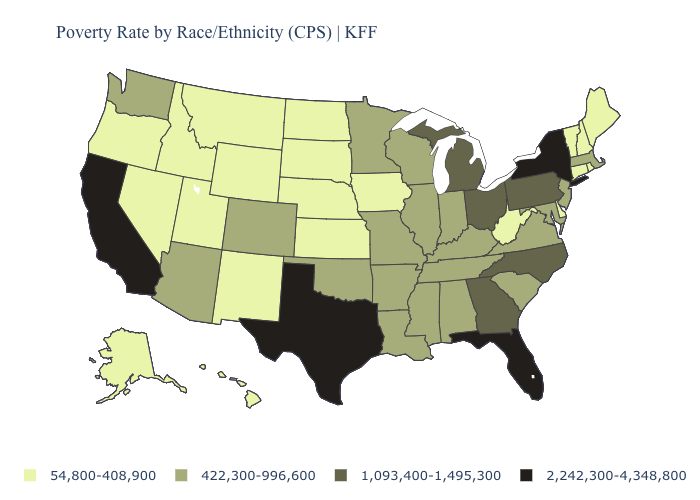Among the states that border New Jersey , does Pennsylvania have the lowest value?
Be succinct. No. What is the value of Washington?
Keep it brief. 422,300-996,600. Which states hav the highest value in the MidWest?
Keep it brief. Michigan, Ohio. What is the lowest value in states that border Maryland?
Be succinct. 54,800-408,900. Among the states that border Utah , does Colorado have the lowest value?
Write a very short answer. No. Among the states that border New Mexico , which have the lowest value?
Answer briefly. Utah. What is the lowest value in states that border Indiana?
Give a very brief answer. 422,300-996,600. What is the value of Vermont?
Be succinct. 54,800-408,900. What is the value of Illinois?
Write a very short answer. 422,300-996,600. What is the lowest value in the Northeast?
Quick response, please. 54,800-408,900. Does Iowa have the lowest value in the MidWest?
Be succinct. Yes. Among the states that border New Hampshire , which have the highest value?
Write a very short answer. Massachusetts. What is the value of Kentucky?
Quick response, please. 422,300-996,600. Which states have the highest value in the USA?
Answer briefly. California, Florida, New York, Texas. Among the states that border Kentucky , does West Virginia have the highest value?
Write a very short answer. No. 